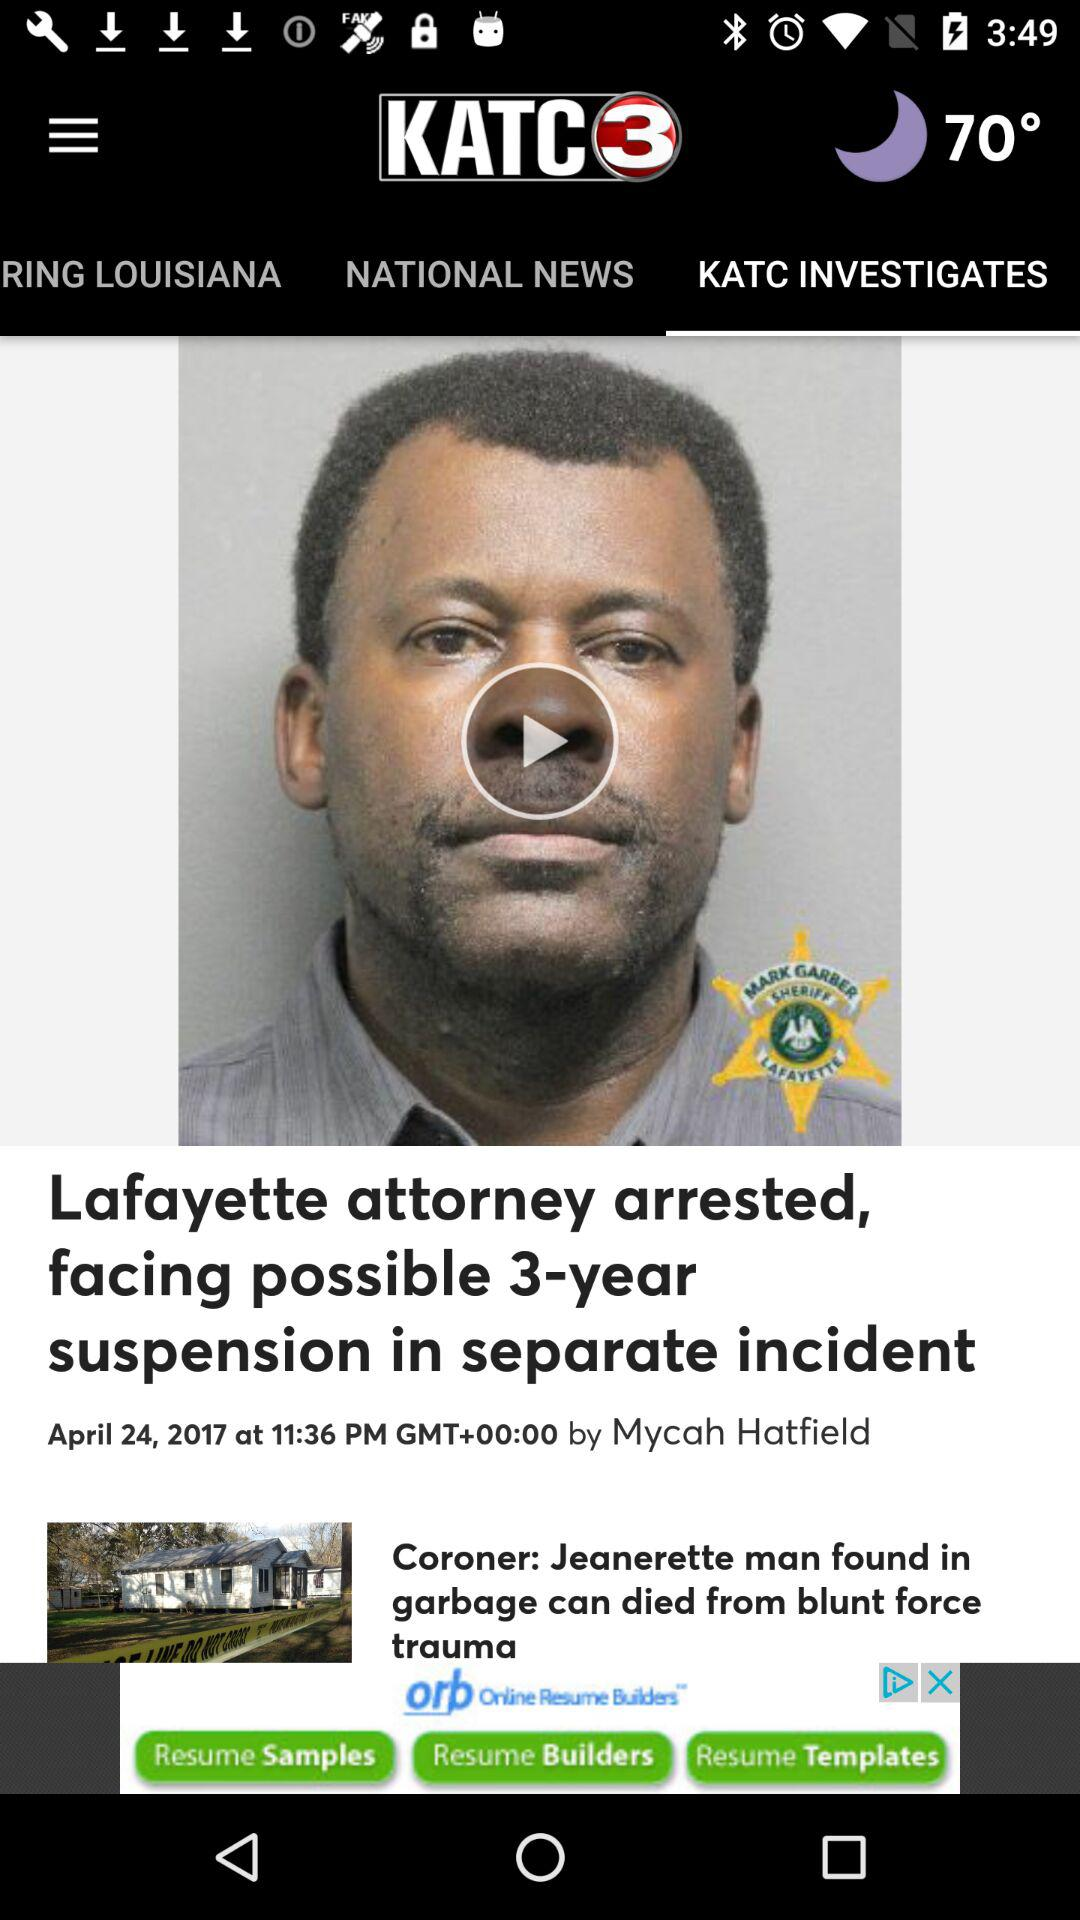What is the name of the news channel? The name of the news channel is "KATC3". 